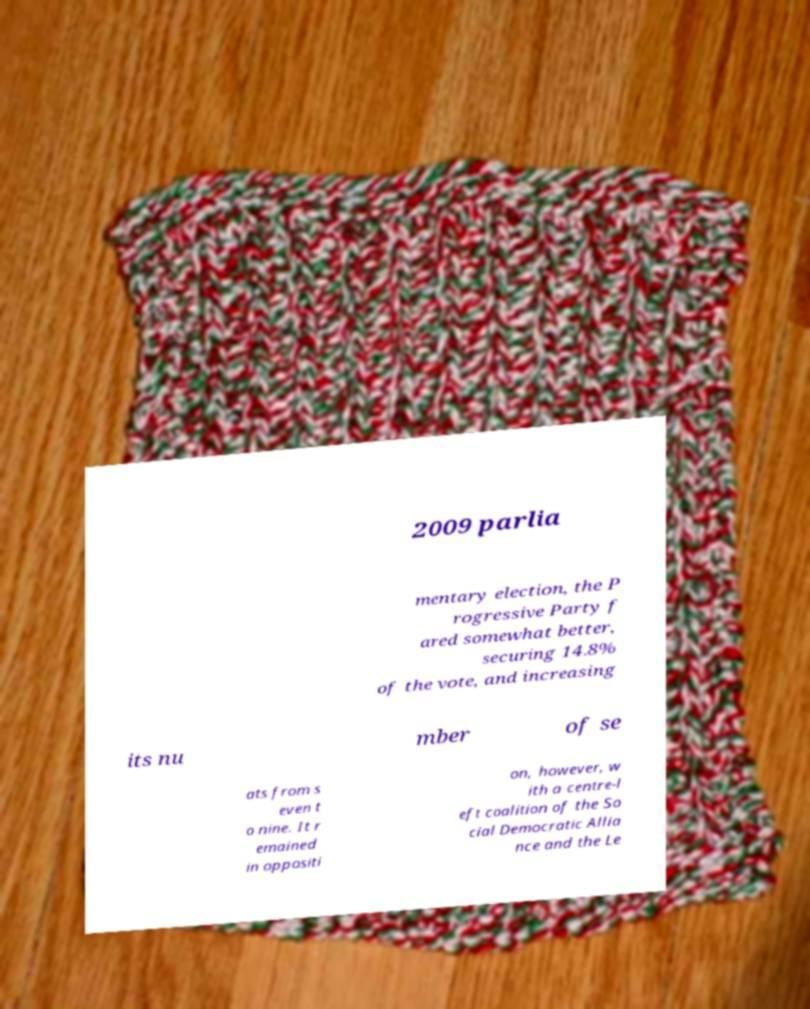Could you assist in decoding the text presented in this image and type it out clearly? 2009 parlia mentary election, the P rogressive Party f ared somewhat better, securing 14.8% of the vote, and increasing its nu mber of se ats from s even t o nine. It r emained in oppositi on, however, w ith a centre-l eft coalition of the So cial Democratic Allia nce and the Le 